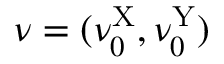Convert formula to latex. <formula><loc_0><loc_0><loc_500><loc_500>\nu = ( \nu _ { 0 } ^ { X } , \nu _ { 0 } ^ { Y } )</formula> 